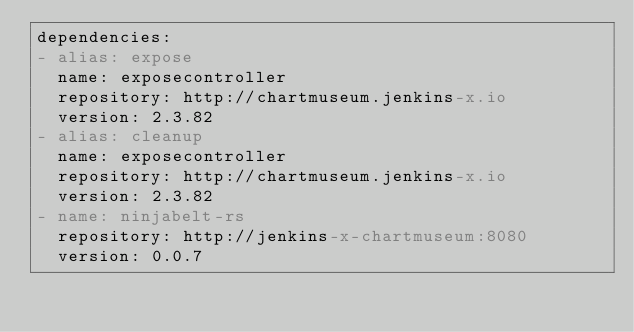<code> <loc_0><loc_0><loc_500><loc_500><_YAML_>dependencies:
- alias: expose
  name: exposecontroller
  repository: http://chartmuseum.jenkins-x.io
  version: 2.3.82
- alias: cleanup
  name: exposecontroller
  repository: http://chartmuseum.jenkins-x.io
  version: 2.3.82
- name: ninjabelt-rs
  repository: http://jenkins-x-chartmuseum:8080
  version: 0.0.7
</code> 